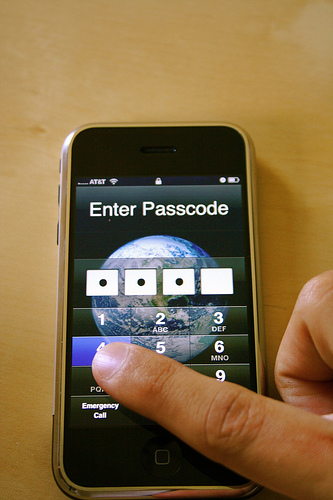<image>
Is the phone in the world? No. The phone is not contained within the world. These objects have a different spatial relationship. 